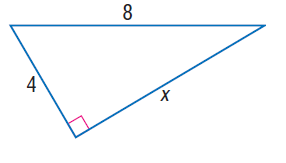Answer the mathemtical geometry problem and directly provide the correct option letter.
Question: Find x.
Choices: A: 2 \sqrt { 3 } B: 4 \sqrt { 3 } C: 4 \sqrt { 5 } D: 4 \sqrt { 6 } B 